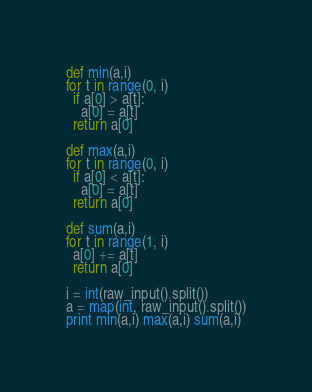Convert code to text. <code><loc_0><loc_0><loc_500><loc_500><_Python_>def min(a,i)
for t in range(0, i)
  if a[0] > a[t]:
    a[0] = a[t]
  return a[0]

def max(a,i)
for t in range(0, i)
  if a[0] < a[t]:
    a[0] = a[t]
  return a[0]

def sum(a,i)
for t in range(1, i)
  a[0] += a[t]
  return a[0]

i = int(raw_input().split())
a = map(int, raw_input().split())
print min(a,i) max(a,i) sum(a,i)</code> 